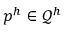<formula> <loc_0><loc_0><loc_500><loc_500>p ^ { h } \in \mathcal { Q } ^ { h }</formula> 